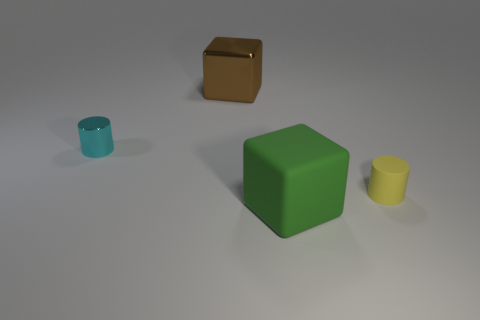What number of tiny yellow matte objects are behind the large object that is behind the cylinder to the right of the large matte object?
Ensure brevity in your answer.  0. How many small yellow rubber cylinders are in front of the brown cube?
Make the answer very short. 1. How many green objects are made of the same material as the tiny yellow cylinder?
Provide a succinct answer. 1. What color is the other large object that is the same material as the cyan object?
Provide a short and direct response. Brown. The object that is behind the tiny thing that is left of the cube that is behind the cyan shiny cylinder is made of what material?
Your response must be concise. Metal. Does the brown thing behind the yellow matte thing have the same size as the yellow matte object?
Your answer should be compact. No. How many large things are either cyan matte cylinders or cyan shiny things?
Keep it short and to the point. 0. Are there any matte objects that have the same color as the small metal object?
Offer a terse response. No. The other object that is the same size as the yellow matte thing is what shape?
Offer a very short reply. Cylinder. Does the small cylinder on the left side of the green cube have the same color as the small rubber object?
Give a very brief answer. No. 